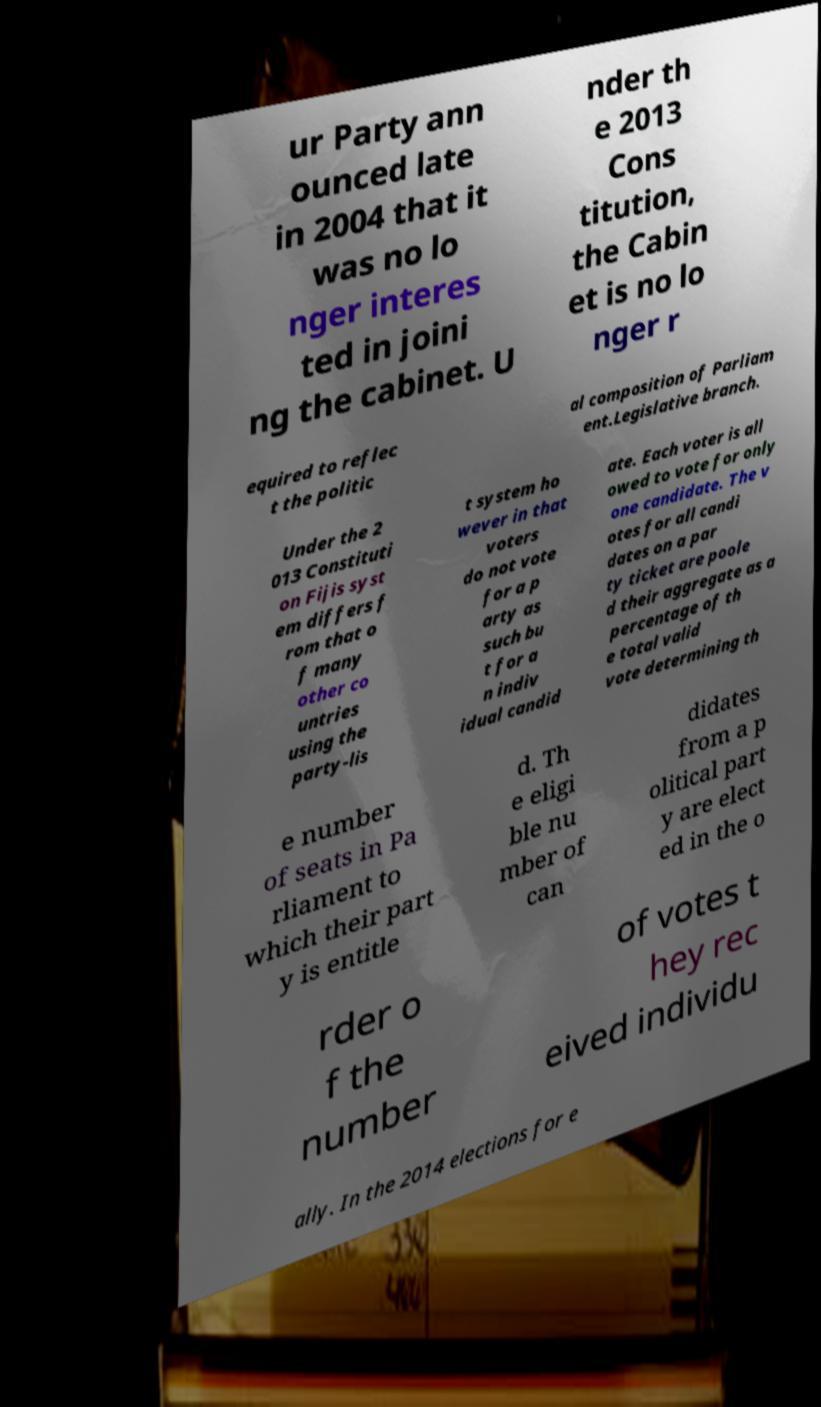I need the written content from this picture converted into text. Can you do that? ur Party ann ounced late in 2004 that it was no lo nger interes ted in joini ng the cabinet. U nder th e 2013 Cons titution, the Cabin et is no lo nger r equired to reflec t the politic al composition of Parliam ent.Legislative branch. Under the 2 013 Constituti on Fijis syst em differs f rom that o f many other co untries using the party-lis t system ho wever in that voters do not vote for a p arty as such bu t for a n indiv idual candid ate. Each voter is all owed to vote for only one candidate. The v otes for all candi dates on a par ty ticket are poole d their aggregate as a percentage of th e total valid vote determining th e number of seats in Pa rliament to which their part y is entitle d. Th e eligi ble nu mber of can didates from a p olitical part y are elect ed in the o rder o f the number of votes t hey rec eived individu ally. In the 2014 elections for e 